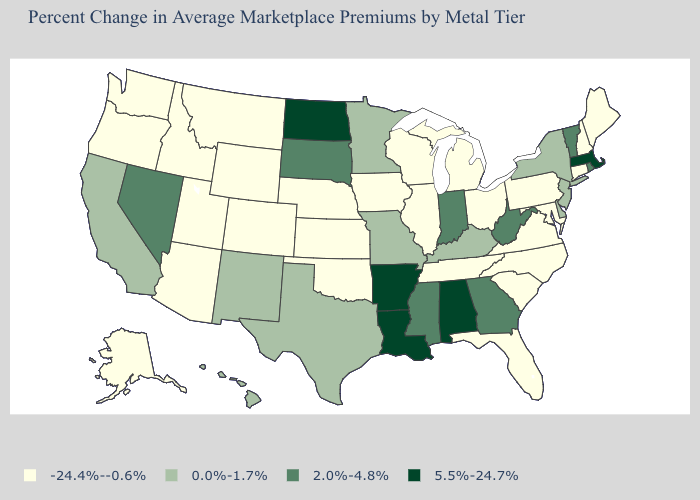What is the value of Kansas?
Write a very short answer. -24.4%--0.6%. Name the states that have a value in the range -24.4%--0.6%?
Quick response, please. Alaska, Arizona, Colorado, Connecticut, Florida, Idaho, Illinois, Iowa, Kansas, Maine, Maryland, Michigan, Montana, Nebraska, New Hampshire, North Carolina, Ohio, Oklahoma, Oregon, Pennsylvania, South Carolina, Tennessee, Utah, Virginia, Washington, Wisconsin, Wyoming. What is the value of Nebraska?
Concise answer only. -24.4%--0.6%. Does the first symbol in the legend represent the smallest category?
Quick response, please. Yes. Name the states that have a value in the range 2.0%-4.8%?
Short answer required. Georgia, Indiana, Mississippi, Nevada, Rhode Island, South Dakota, Vermont, West Virginia. Among the states that border New York , which have the highest value?
Be succinct. Massachusetts. Does North Dakota have the highest value in the MidWest?
Keep it brief. Yes. Among the states that border New York , does Massachusetts have the lowest value?
Give a very brief answer. No. Does the first symbol in the legend represent the smallest category?
Write a very short answer. Yes. Does West Virginia have the highest value in the USA?
Write a very short answer. No. Name the states that have a value in the range 5.5%-24.7%?
Concise answer only. Alabama, Arkansas, Louisiana, Massachusetts, North Dakota. What is the highest value in states that border Pennsylvania?
Keep it brief. 2.0%-4.8%. Name the states that have a value in the range 0.0%-1.7%?
Give a very brief answer. California, Delaware, Hawaii, Kentucky, Minnesota, Missouri, New Jersey, New Mexico, New York, Texas. Name the states that have a value in the range 2.0%-4.8%?
Write a very short answer. Georgia, Indiana, Mississippi, Nevada, Rhode Island, South Dakota, Vermont, West Virginia. Name the states that have a value in the range 0.0%-1.7%?
Short answer required. California, Delaware, Hawaii, Kentucky, Minnesota, Missouri, New Jersey, New Mexico, New York, Texas. 